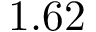Convert formula to latex. <formula><loc_0><loc_0><loc_500><loc_500>1 . 6 2</formula> 